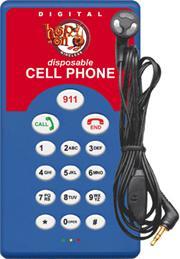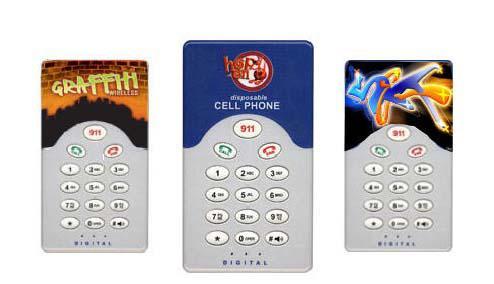The first image is the image on the left, the second image is the image on the right. Assess this claim about the two images: "The left image contains no more than two phones, and the right image shows a messy pile of at least a dozen phones.". Correct or not? Answer yes or no. No. The first image is the image on the left, the second image is the image on the right. Examine the images to the left and right. Is the description "In at least one image there is no more than three standing phones that have at least thirteen buttons." accurate? Answer yes or no. Yes. 